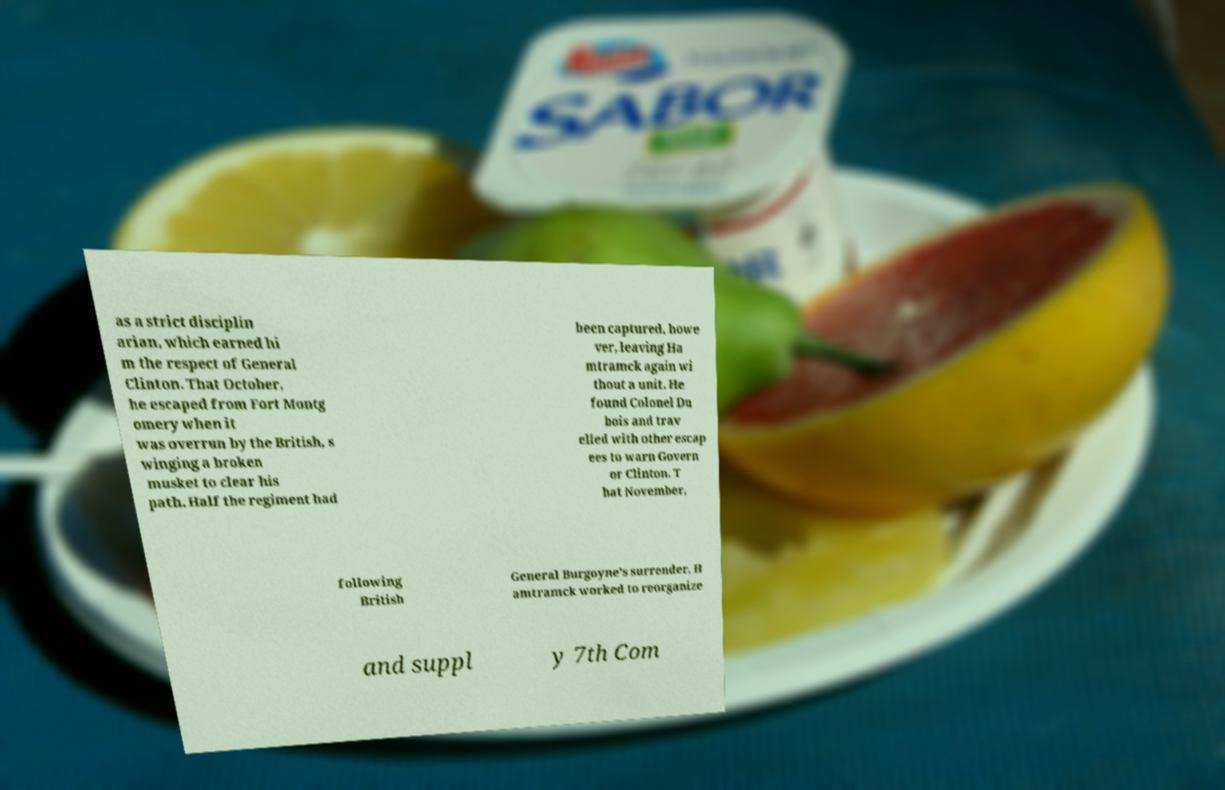Could you extract and type out the text from this image? as a strict disciplin arian, which earned hi m the respect of General Clinton. That October, he escaped from Fort Montg omery when it was overrun by the British, s winging a broken musket to clear his path. Half the regiment had been captured, howe ver, leaving Ha mtramck again wi thout a unit. He found Colonel Du bois and trav elled with other escap ees to warn Govern or Clinton. T hat November, following British General Burgoyne's surrender, H amtramck worked to reorganize and suppl y 7th Com 